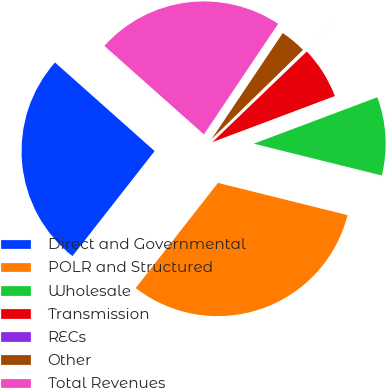Convert chart to OTSL. <chart><loc_0><loc_0><loc_500><loc_500><pie_chart><fcel>Direct and Governmental<fcel>POLR and Structured<fcel>Wholesale<fcel>Transmission<fcel>RECs<fcel>Other<fcel>Total Revenues<nl><fcel>26.0%<fcel>31.69%<fcel>9.6%<fcel>6.45%<fcel>0.13%<fcel>3.29%<fcel>22.84%<nl></chart> 